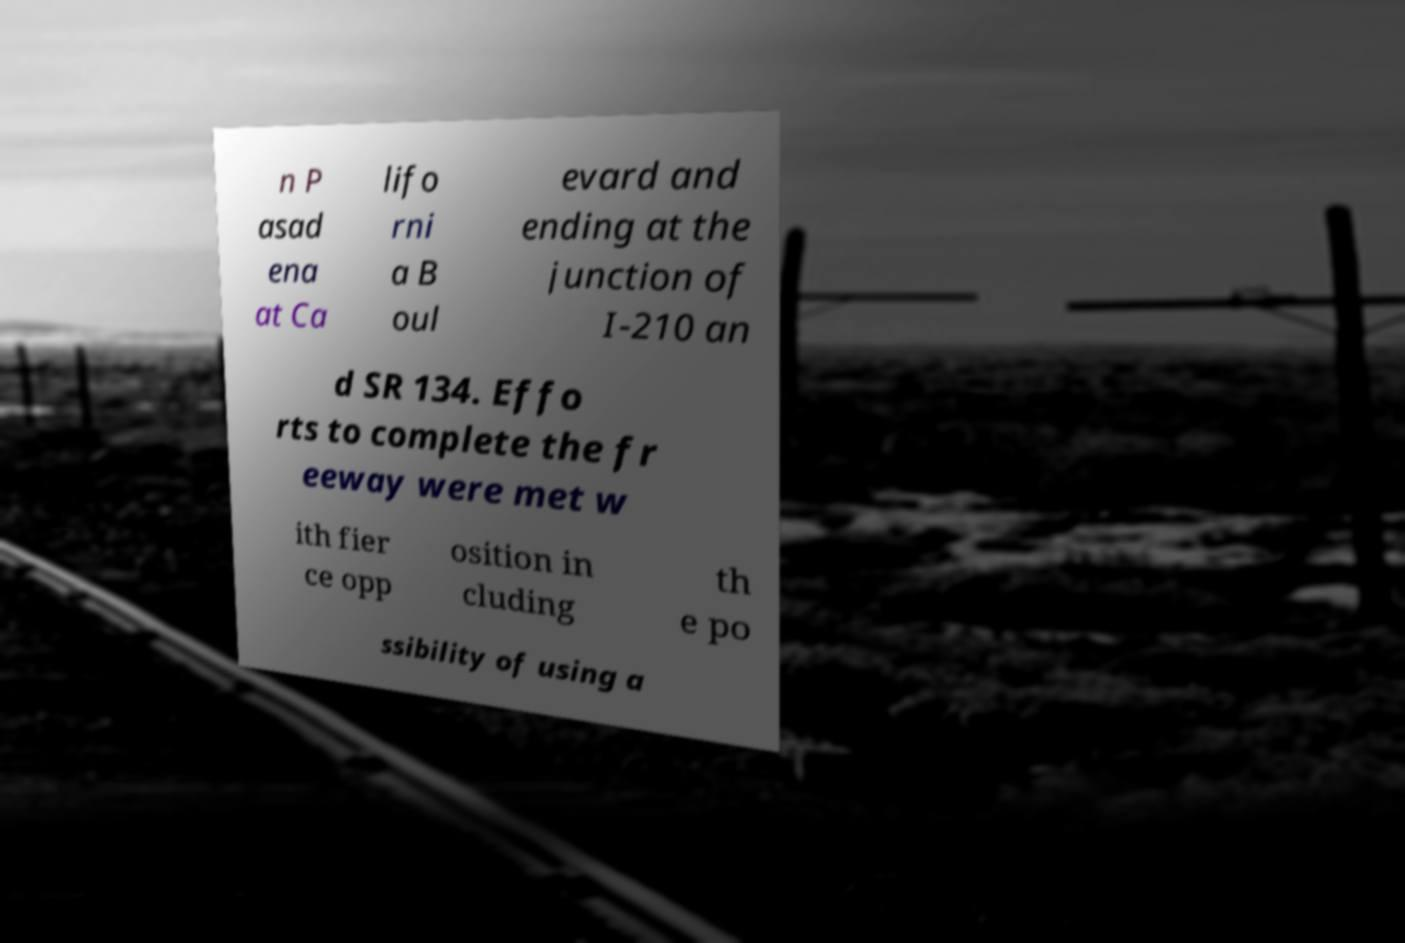There's text embedded in this image that I need extracted. Can you transcribe it verbatim? n P asad ena at Ca lifo rni a B oul evard and ending at the junction of I-210 an d SR 134. Effo rts to complete the fr eeway were met w ith fier ce opp osition in cluding th e po ssibility of using a 